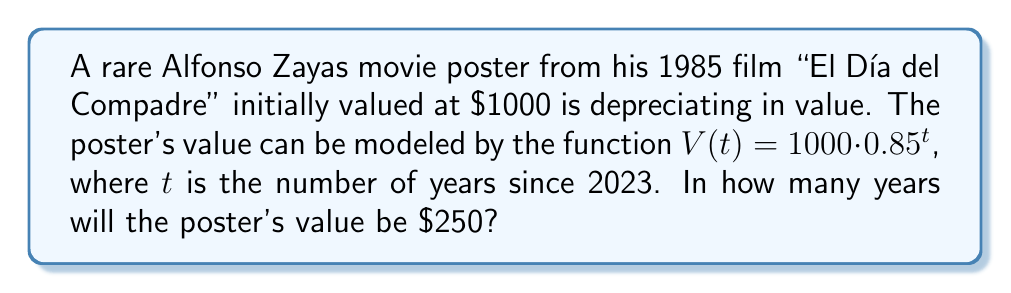Can you solve this math problem? Let's approach this step-by-step:

1) We're given the function $V(t) = 1000 \cdot 0.85^t$, where $V(t)$ is the value after $t$ years.

2) We want to find when $V(t) = 250$. So, let's set up the equation:

   $250 = 1000 \cdot 0.85^t$

3) Divide both sides by 1000:

   $0.25 = 0.85^t$

4) To solve for $t$, we need to use logarithms. Let's apply $\log$ to both sides:

   $\log(0.25) = \log(0.85^t)$

5) Using the logarithm property $\log(a^b) = b\log(a)$, we get:

   $\log(0.25) = t \cdot \log(0.85)$

6) Now we can solve for $t$:

   $t = \frac{\log(0.25)}{\log(0.85)}$

7) Using a calculator or computer:

   $t \approx 8.97$ years

8) Since we're dealing with whole years, we round up to 9 years.
Answer: 9 years 